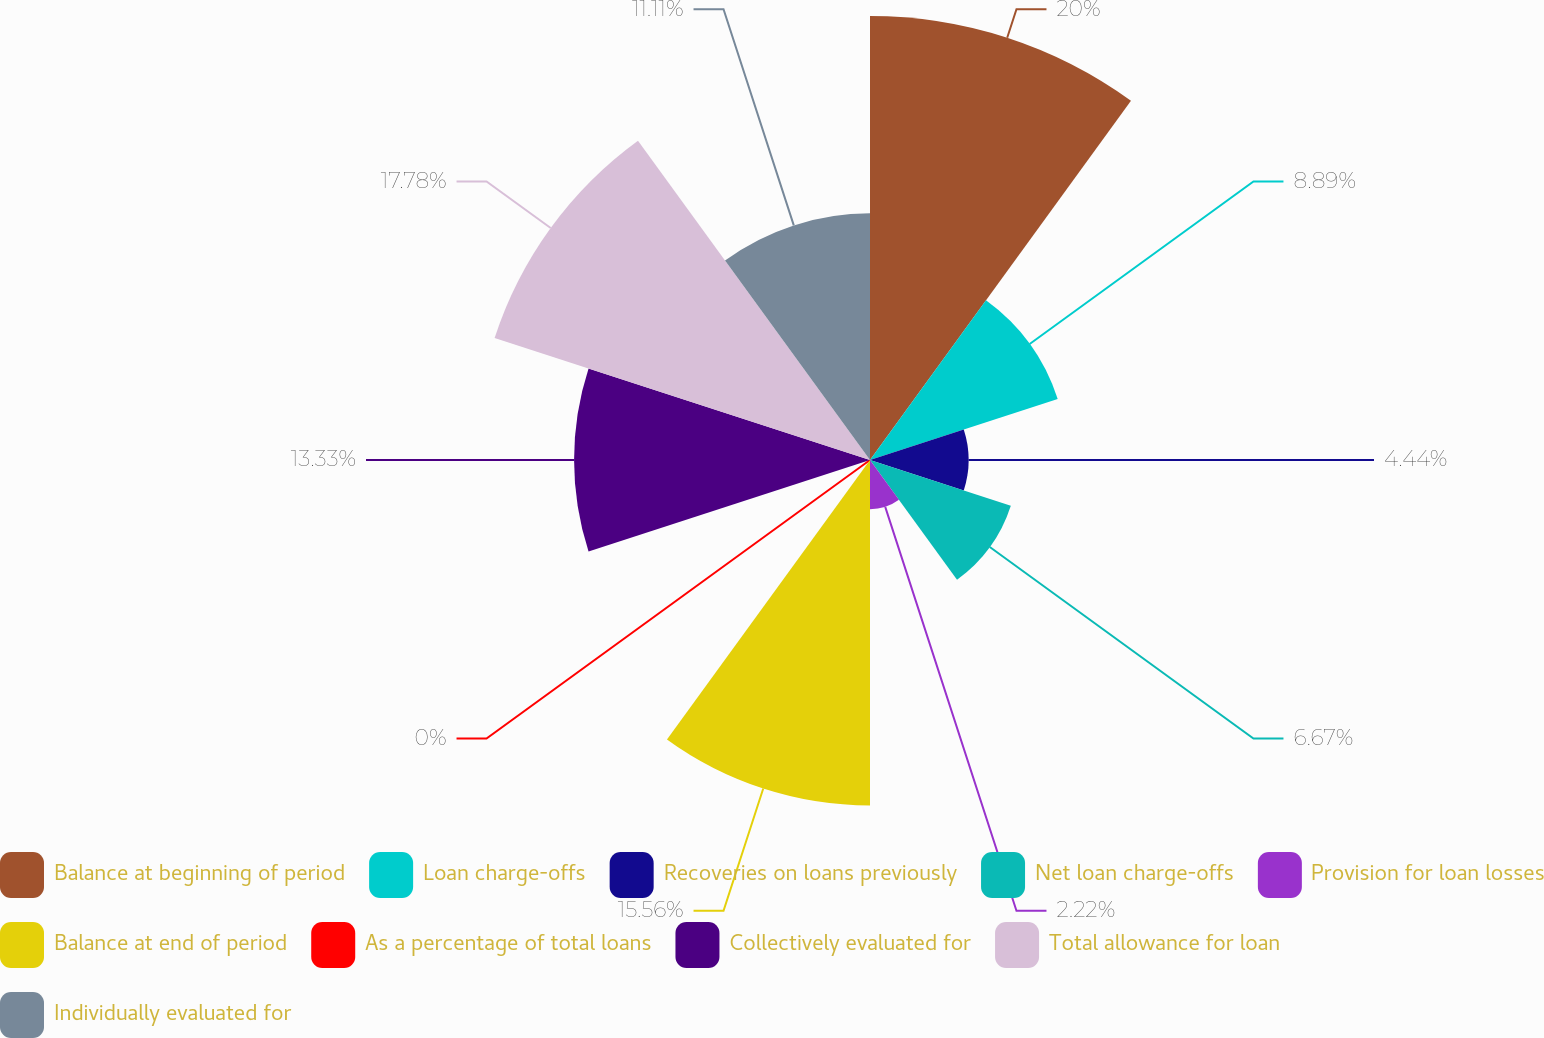Convert chart. <chart><loc_0><loc_0><loc_500><loc_500><pie_chart><fcel>Balance at beginning of period<fcel>Loan charge-offs<fcel>Recoveries on loans previously<fcel>Net loan charge-offs<fcel>Provision for loan losses<fcel>Balance at end of period<fcel>As a percentage of total loans<fcel>Collectively evaluated for<fcel>Total allowance for loan<fcel>Individually evaluated for<nl><fcel>20.0%<fcel>8.89%<fcel>4.44%<fcel>6.67%<fcel>2.22%<fcel>15.56%<fcel>0.0%<fcel>13.33%<fcel>17.78%<fcel>11.11%<nl></chart> 